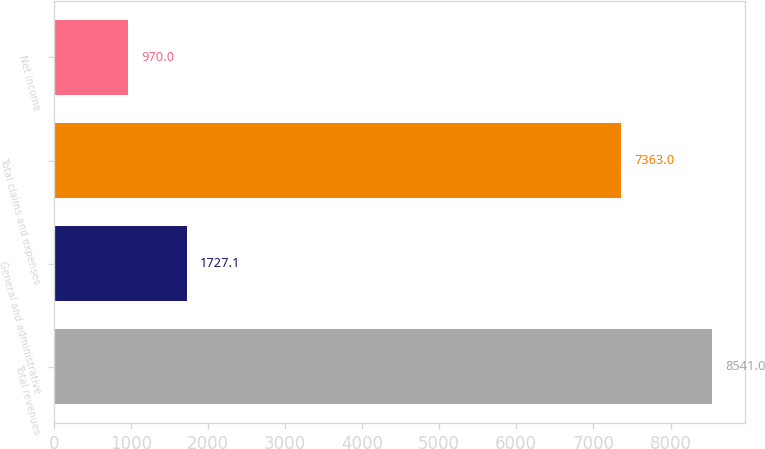Convert chart. <chart><loc_0><loc_0><loc_500><loc_500><bar_chart><fcel>Total revenues<fcel>General and administrative<fcel>Total claims and expenses<fcel>Net income<nl><fcel>8541<fcel>1727.1<fcel>7363<fcel>970<nl></chart> 